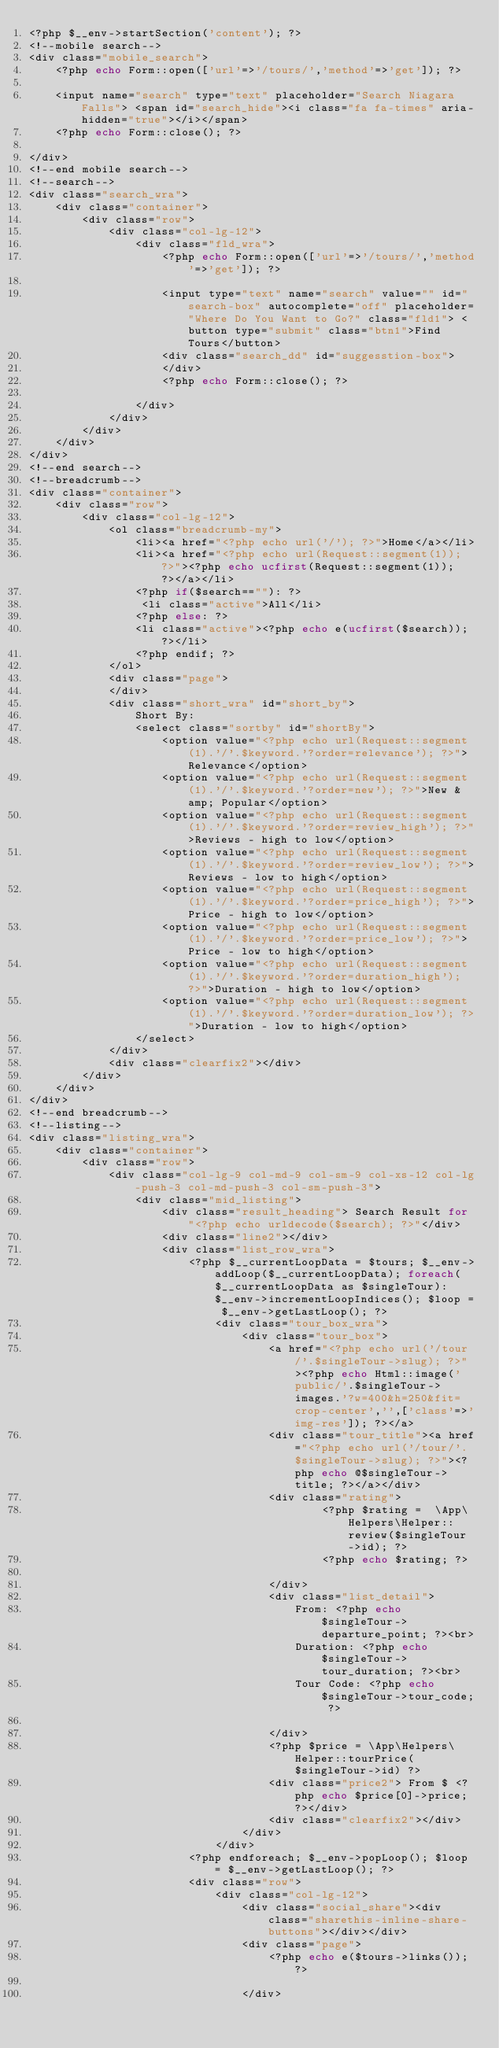<code> <loc_0><loc_0><loc_500><loc_500><_PHP_><?php $__env->startSection('content'); ?>
<!--mobile search-->
<div class="mobile_search">
    <?php echo Form::open(['url'=>'/tours/','method'=>'get']); ?>

    <input name="search" type="text" placeholder="Search Niagara Falls"> <span id="search_hide"><i class="fa fa-times" aria-hidden="true"></i></span>
    <?php echo Form::close(); ?>

</div>
<!--end mobile search-->
<!--search-->
<div class="search_wra">
    <div class="container">
        <div class="row">
            <div class="col-lg-12">
                <div class="fld_wra">
                    <?php echo Form::open(['url'=>'/tours/','method'=>'get']); ?>

                    <input type="text" name="search" value="" id="search-box" autocomplete="off" placeholder="Where Do You Want to Go?" class="fld1"> <button type="submit" class="btn1">Find Tours</button>
                    <div class="search_dd" id="suggesstion-box">
                    </div>
                    <?php echo Form::close(); ?>

                </div>
            </div>
        </div>
    </div>
</div>
<!--end search-->
<!--breadcrumb-->
<div class="container">
    <div class="row">
        <div class="col-lg-12">
            <ol class="breadcrumb-my">
                <li><a href="<?php echo url('/'); ?>">Home</a></li>
                <li><a href="<?php echo url(Request::segment(1)); ?>"><?php echo ucfirst(Request::segment(1)); ?></a></li>
                <?php if($search==""): ?>
                 <li class="active">All</li>
                <?php else: ?>
                <li class="active"><?php echo e(ucfirst($search)); ?></li>
                <?php endif; ?>
            </ol>
            <div class="page">
            </div>
            <div class="short_wra" id="short_by">
                Short By:
                <select class="sortby" id="shortBy">
                    <option value="<?php echo url(Request::segment(1).'/'.$keyword.'?order=relevance'); ?>">Relevance</option>
                    <option value="<?php echo url(Request::segment(1).'/'.$keyword.'?order=new'); ?>">New &amp; Popular</option>
                    <option value="<?php echo url(Request::segment(1).'/'.$keyword.'?order=review_high'); ?>">Reviews - high to low</option>
                    <option value="<?php echo url(Request::segment(1).'/'.$keyword.'?order=review_low'); ?>">Reviews - low to high</option>
                    <option value="<?php echo url(Request::segment(1).'/'.$keyword.'?order=price_high'); ?>">Price - high to low</option>
                    <option value="<?php echo url(Request::segment(1).'/'.$keyword.'?order=price_low'); ?>">Price - low to high</option>
                    <option value="<?php echo url(Request::segment(1).'/'.$keyword.'?order=duration_high'); ?>">Duration - high to low</option>
                    <option value="<?php echo url(Request::segment(1).'/'.$keyword.'?order=duration_low'); ?>">Duration - low to high</option>
                </select>
            </div>
            <div class="clearfix2"></div>
        </div>
    </div>
</div>
<!--end breadcrumb-->
<!--listing-->
<div class="listing_wra">
    <div class="container">
        <div class="row">
            <div class="col-lg-9 col-md-9 col-sm-9 col-xs-12 col-lg-push-3 col-md-push-3 col-sm-push-3">
                <div class="mid_listing">
                    <div class="result_heading"> Search Result for "<?php echo urldecode($search); ?>"</div>
                    <div class="line2"></div>
                    <div class="list_row_wra">
                        <?php $__currentLoopData = $tours; $__env->addLoop($__currentLoopData); foreach($__currentLoopData as $singleTour): $__env->incrementLoopIndices(); $loop = $__env->getLastLoop(); ?>
                            <div class="tour_box_wra">
                                <div class="tour_box">
                                    <a href="<?php echo url('/tour/'.$singleTour->slug); ?>"><?php echo Html::image('public/'.$singleTour->images.'?w=400&h=250&fit=crop-center','',['class'=>'img-res']); ?></a>
                                    <div class="tour_title"><a href="<?php echo url('/tour/'.$singleTour->slug); ?>"><?php echo @$singleTour->title; ?></a></div>
                                    <div class="rating">
                                            <?php $rating =  \App\Helpers\Helper::review($singleTour->id); ?>
                                            <?php echo $rating; ?>

                                    </div>
                                    <div class="list_detail">
                                        From: <?php echo $singleTour->departure_point; ?><br>
                                        Duration: <?php echo $singleTour->tour_duration; ?><br>
                                        Tour Code: <?php echo $singleTour->tour_code; ?>

                                    </div>
                                    <?php $price = \App\Helpers\Helper::tourPrice($singleTour->id) ?>
                                    <div class="price2"> From $ <?php echo $price[0]->price; ?></div>
                                    <div class="clearfix2"></div>
                                </div>
                            </div>
                        <?php endforeach; $__env->popLoop(); $loop = $__env->getLastLoop(); ?>
                        <div class="row">
                            <div class="col-lg-12">
                                <div class="social_share"><div class="sharethis-inline-share-buttons"></div></div>
                                <div class="page">
                                    <?php echo e($tours->links()); ?>

                                </div></code> 